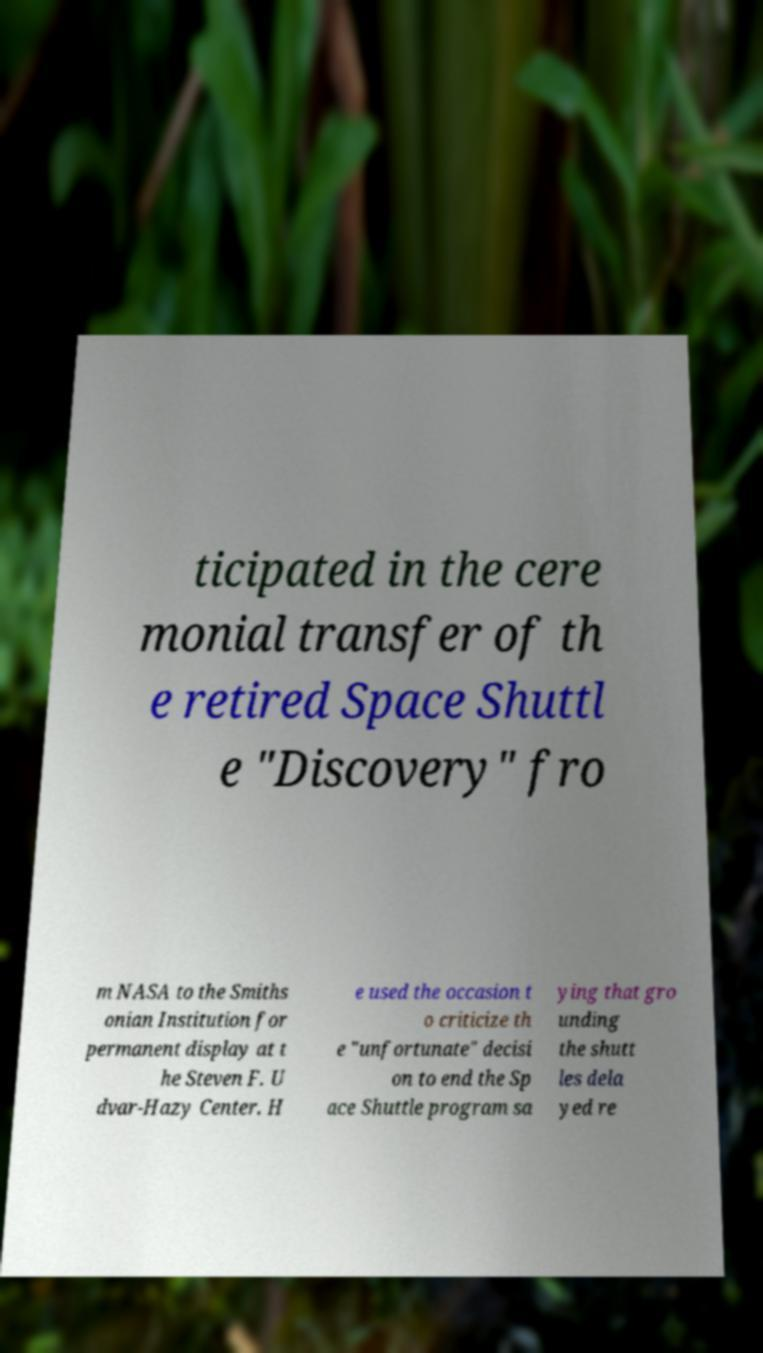What messages or text are displayed in this image? I need them in a readable, typed format. ticipated in the cere monial transfer of th e retired Space Shuttl e "Discovery" fro m NASA to the Smiths onian Institution for permanent display at t he Steven F. U dvar-Hazy Center. H e used the occasion t o criticize th e "unfortunate" decisi on to end the Sp ace Shuttle program sa ying that gro unding the shutt les dela yed re 